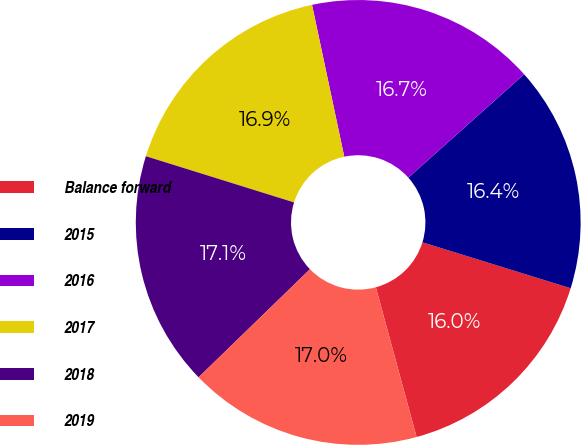Convert chart to OTSL. <chart><loc_0><loc_0><loc_500><loc_500><pie_chart><fcel>Balance forward<fcel>2015<fcel>2016<fcel>2017<fcel>2018<fcel>2019<nl><fcel>15.99%<fcel>16.38%<fcel>16.73%<fcel>16.86%<fcel>17.07%<fcel>16.97%<nl></chart> 